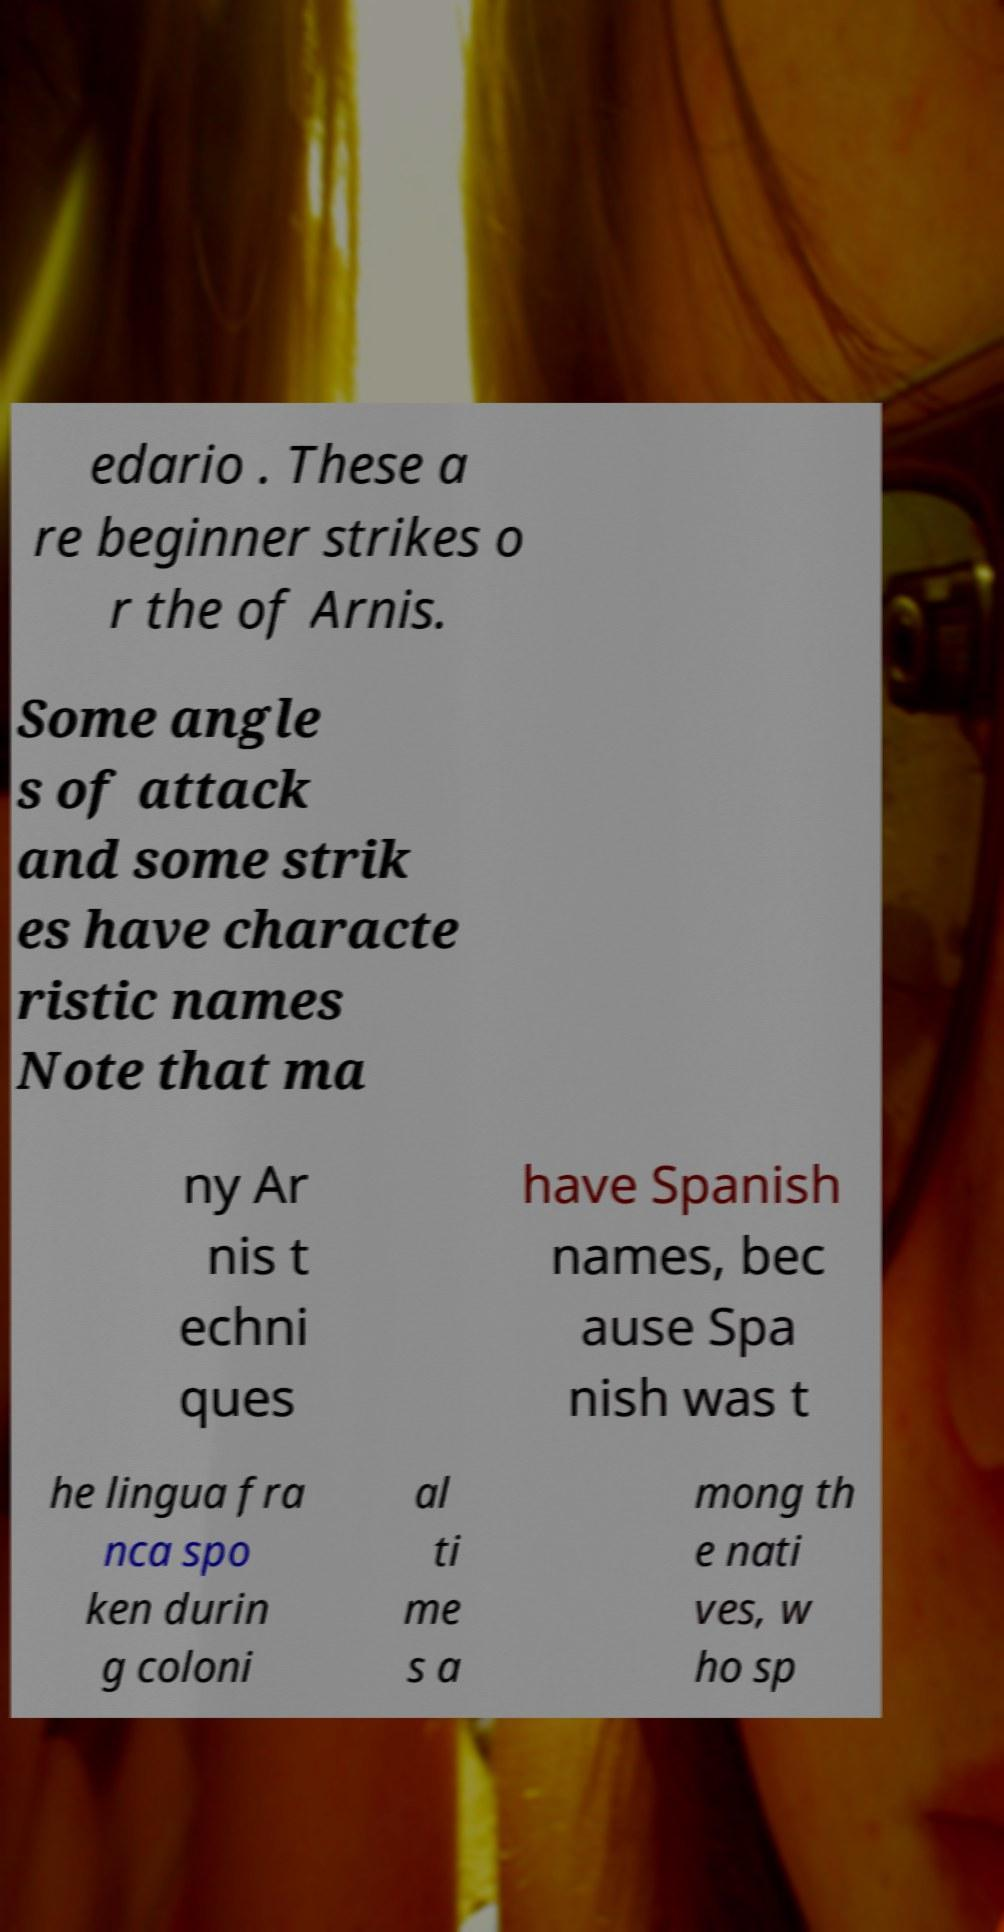For documentation purposes, I need the text within this image transcribed. Could you provide that? edario . These a re beginner strikes o r the of Arnis. Some angle s of attack and some strik es have characte ristic names Note that ma ny Ar nis t echni ques have Spanish names, bec ause Spa nish was t he lingua fra nca spo ken durin g coloni al ti me s a mong th e nati ves, w ho sp 